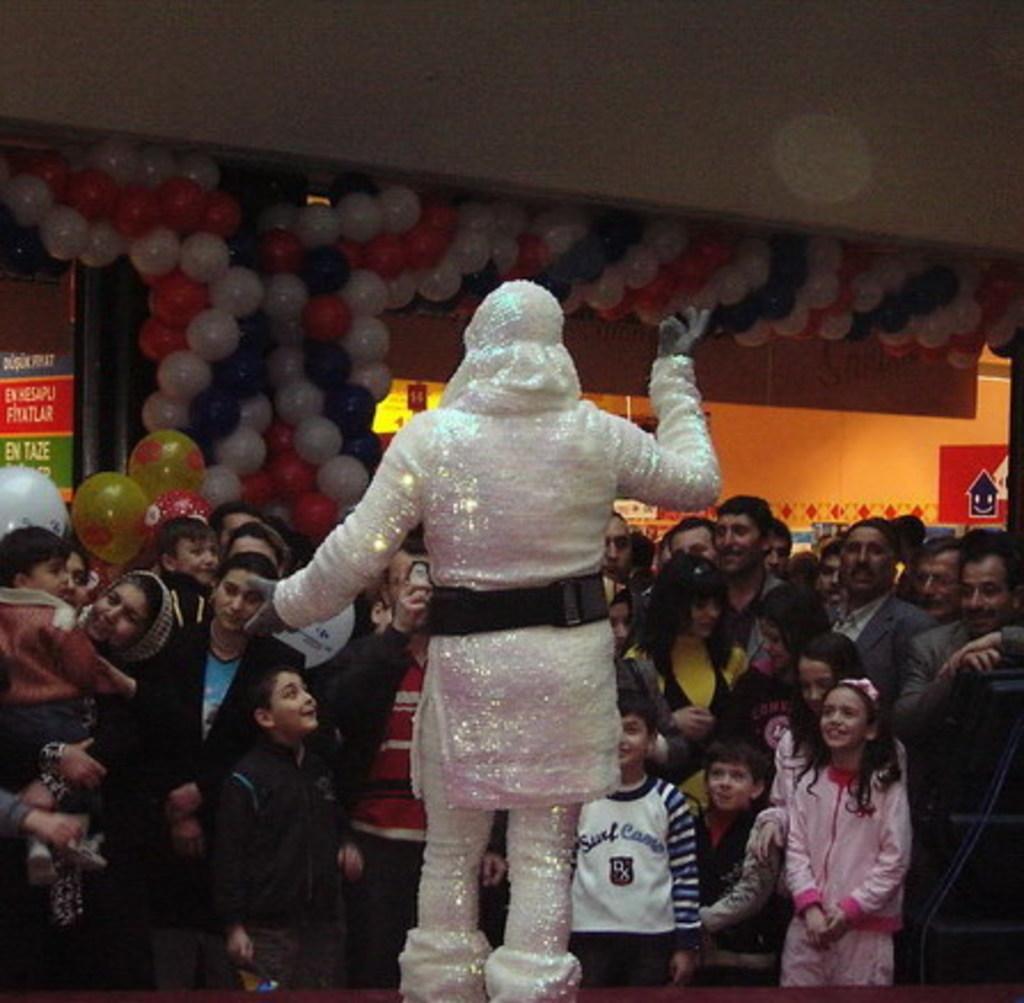Could you give a brief overview of what you see in this image? In this picture we can see a person in the fancy dress is standing and in front of the person there are some people standing and balloons on the wall and other things. 